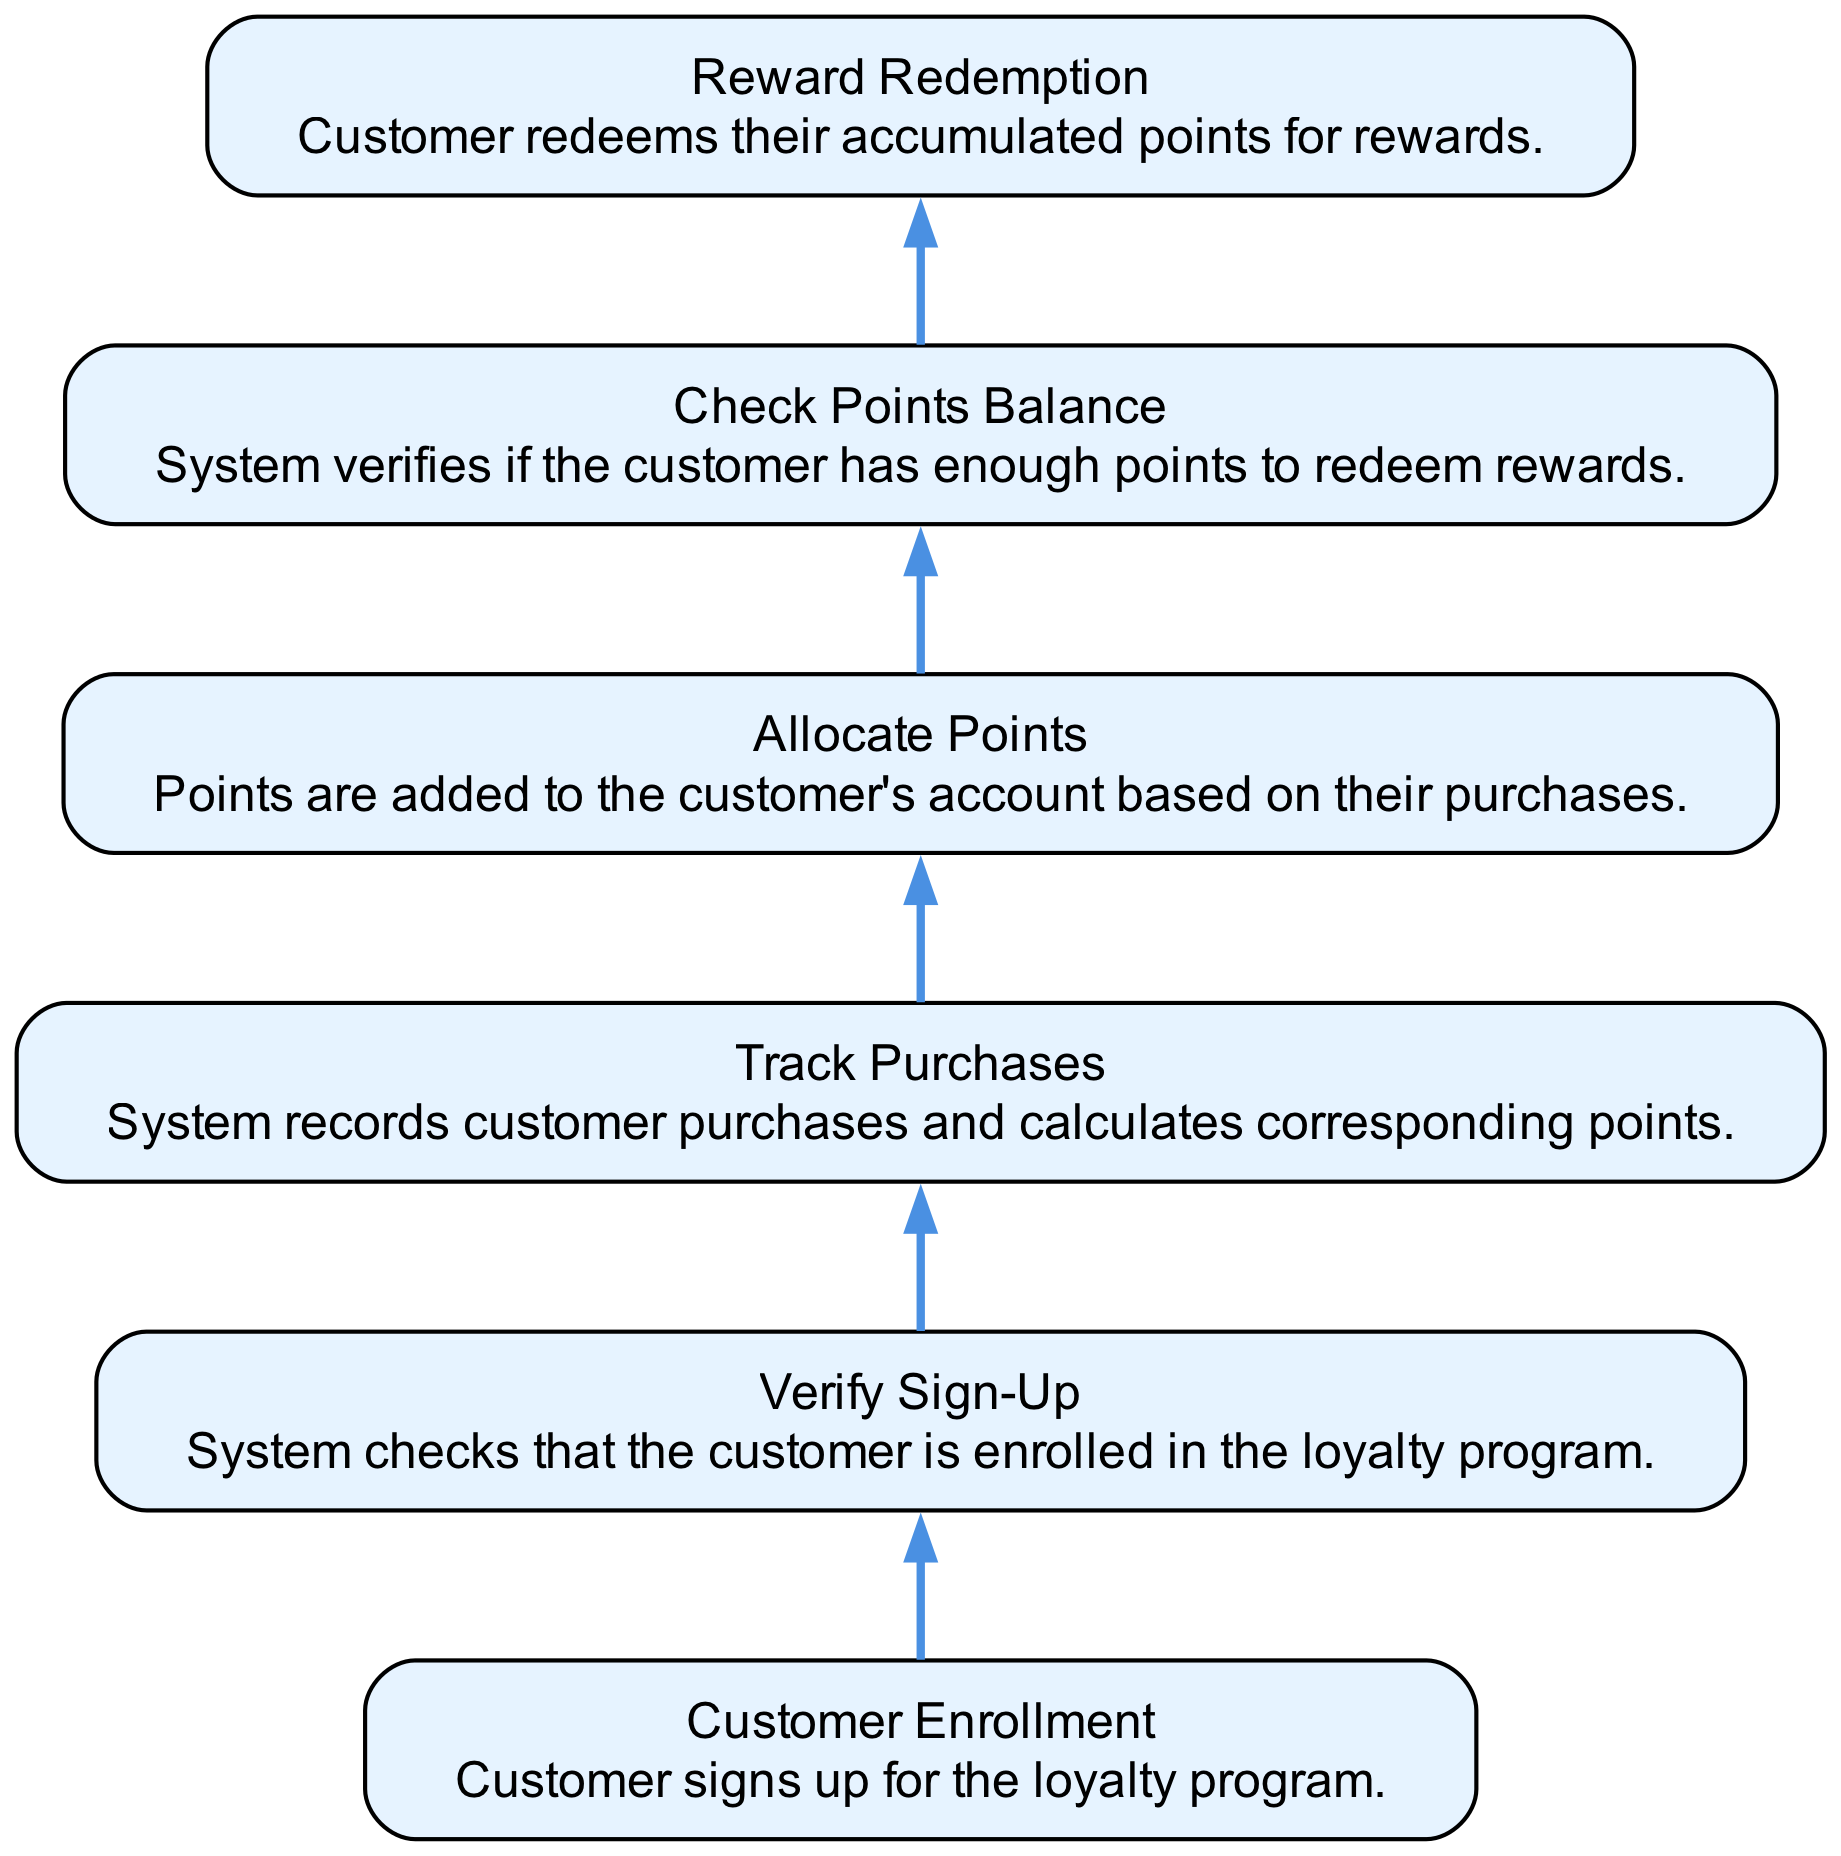What is the final step in this flowchart? The final step is "Reward Redemption," where customers redeem their accumulated points for rewards.
Answer: Reward Redemption How many overall steps are there in the process shown? There are six steps total in the process, from "Customer Enrollment" to "Reward Redemption."
Answer: Six What happens after "Allocate Points"? After "Allocate Points," the system verifies the customer's points through "Check Points Balance."
Answer: Check Points Balance Which step follows "Verify Sign-Up"? The step that follows "Verify Sign-Up" is "Track Purchases," where customer purchases are recorded and points calculated.
Answer: Track Purchases If a customer has an issue with redeeming rewards, which step should they check? They should check "Check Points Balance" as it verifies if they have enough points to redeem rewards.
Answer: Check Points Balance What is the relationship between "Customer Enrollment" and "Verify Sign-Up"? "Verify Sign-Up" is dependent on "Customer Enrollment," indicating that a customer must first enroll before sign-up verification occurs.
Answer: Dependent What is the purpose of the "Track Purchases" step? The purpose is to record customer purchases and calculate the corresponding points earned based on their spending.
Answer: Record purchases and calculate points In what order do the steps occur from bottom to top? The order is: Customer Enrollment, Verify Sign-Up, Track Purchases, Allocate Points, Check Points Balance, Reward Redemption.
Answer: Customer Enrollment, Verify Sign-Up, Track Purchases, Allocate Points, Check Points Balance, Reward Redemption How does "Allocate Points" affect the next step? "Allocate Points" impacts the subsequent step "Check Points Balance" by ensuring points are added based on purchases before balance verification.
Answer: Ensures point allocation before balance check 